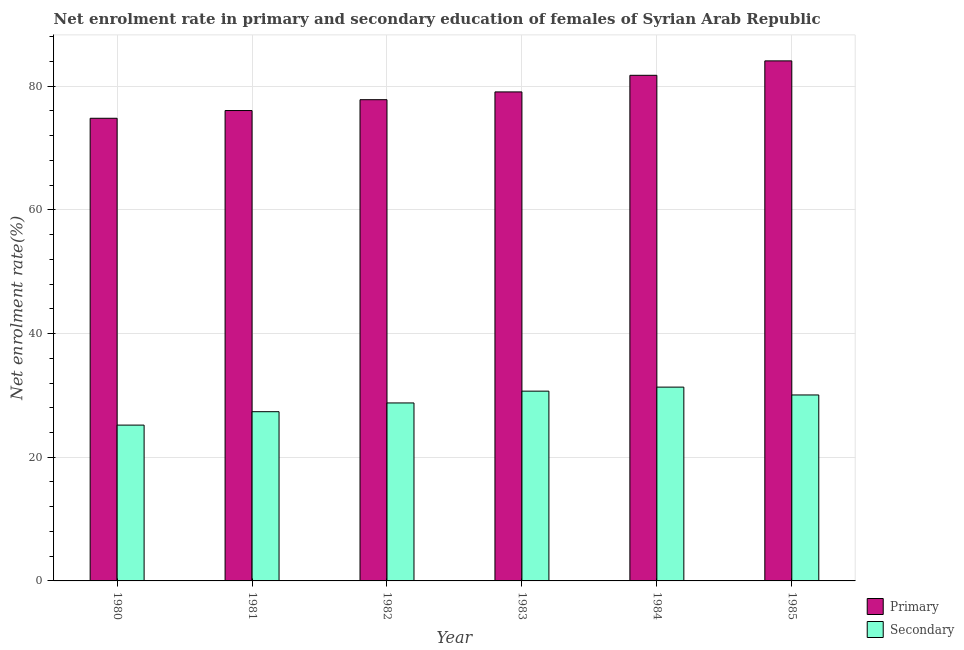How many different coloured bars are there?
Offer a very short reply. 2. How many groups of bars are there?
Provide a short and direct response. 6. Are the number of bars on each tick of the X-axis equal?
Provide a succinct answer. Yes. How many bars are there on the 6th tick from the left?
Provide a short and direct response. 2. What is the enrollment rate in primary education in 1984?
Provide a short and direct response. 81.76. Across all years, what is the maximum enrollment rate in primary education?
Keep it short and to the point. 84.09. Across all years, what is the minimum enrollment rate in secondary education?
Give a very brief answer. 25.2. What is the total enrollment rate in primary education in the graph?
Give a very brief answer. 473.62. What is the difference between the enrollment rate in primary education in 1981 and that in 1982?
Offer a very short reply. -1.75. What is the difference between the enrollment rate in primary education in 1982 and the enrollment rate in secondary education in 1983?
Give a very brief answer. -1.26. What is the average enrollment rate in secondary education per year?
Your answer should be compact. 28.91. In how many years, is the enrollment rate in primary education greater than 12 %?
Provide a succinct answer. 6. What is the ratio of the enrollment rate in secondary education in 1982 to that in 1983?
Keep it short and to the point. 0.94. Is the enrollment rate in secondary education in 1981 less than that in 1983?
Offer a terse response. Yes. What is the difference between the highest and the second highest enrollment rate in secondary education?
Make the answer very short. 0.65. What is the difference between the highest and the lowest enrollment rate in primary education?
Keep it short and to the point. 9.28. In how many years, is the enrollment rate in primary education greater than the average enrollment rate in primary education taken over all years?
Offer a very short reply. 3. What does the 1st bar from the left in 1980 represents?
Provide a succinct answer. Primary. What does the 2nd bar from the right in 1984 represents?
Ensure brevity in your answer.  Primary. How many bars are there?
Offer a terse response. 12. Are all the bars in the graph horizontal?
Your answer should be compact. No. Are the values on the major ticks of Y-axis written in scientific E-notation?
Your response must be concise. No. Where does the legend appear in the graph?
Your answer should be very brief. Bottom right. How are the legend labels stacked?
Your answer should be very brief. Vertical. What is the title of the graph?
Your response must be concise. Net enrolment rate in primary and secondary education of females of Syrian Arab Republic. What is the label or title of the X-axis?
Give a very brief answer. Year. What is the label or title of the Y-axis?
Offer a very short reply. Net enrolment rate(%). What is the Net enrolment rate(%) of Primary in 1980?
Ensure brevity in your answer.  74.81. What is the Net enrolment rate(%) in Secondary in 1980?
Offer a terse response. 25.2. What is the Net enrolment rate(%) in Primary in 1981?
Provide a succinct answer. 76.06. What is the Net enrolment rate(%) of Secondary in 1981?
Offer a very short reply. 27.37. What is the Net enrolment rate(%) in Primary in 1982?
Ensure brevity in your answer.  77.82. What is the Net enrolment rate(%) in Secondary in 1982?
Ensure brevity in your answer.  28.78. What is the Net enrolment rate(%) of Primary in 1983?
Your answer should be very brief. 79.07. What is the Net enrolment rate(%) of Secondary in 1983?
Make the answer very short. 30.69. What is the Net enrolment rate(%) of Primary in 1984?
Keep it short and to the point. 81.76. What is the Net enrolment rate(%) in Secondary in 1984?
Your response must be concise. 31.34. What is the Net enrolment rate(%) in Primary in 1985?
Your response must be concise. 84.09. What is the Net enrolment rate(%) in Secondary in 1985?
Offer a very short reply. 30.07. Across all years, what is the maximum Net enrolment rate(%) in Primary?
Provide a succinct answer. 84.09. Across all years, what is the maximum Net enrolment rate(%) in Secondary?
Offer a very short reply. 31.34. Across all years, what is the minimum Net enrolment rate(%) of Primary?
Keep it short and to the point. 74.81. Across all years, what is the minimum Net enrolment rate(%) in Secondary?
Your answer should be compact. 25.2. What is the total Net enrolment rate(%) in Primary in the graph?
Your response must be concise. 473.62. What is the total Net enrolment rate(%) in Secondary in the graph?
Give a very brief answer. 173.44. What is the difference between the Net enrolment rate(%) of Primary in 1980 and that in 1981?
Provide a succinct answer. -1.25. What is the difference between the Net enrolment rate(%) of Secondary in 1980 and that in 1981?
Give a very brief answer. -2.17. What is the difference between the Net enrolment rate(%) in Primary in 1980 and that in 1982?
Your response must be concise. -3. What is the difference between the Net enrolment rate(%) of Secondary in 1980 and that in 1982?
Make the answer very short. -3.58. What is the difference between the Net enrolment rate(%) of Primary in 1980 and that in 1983?
Your answer should be compact. -4.26. What is the difference between the Net enrolment rate(%) of Secondary in 1980 and that in 1983?
Ensure brevity in your answer.  -5.49. What is the difference between the Net enrolment rate(%) in Primary in 1980 and that in 1984?
Your response must be concise. -6.95. What is the difference between the Net enrolment rate(%) of Secondary in 1980 and that in 1984?
Your answer should be compact. -6.14. What is the difference between the Net enrolment rate(%) in Primary in 1980 and that in 1985?
Your answer should be compact. -9.28. What is the difference between the Net enrolment rate(%) of Secondary in 1980 and that in 1985?
Make the answer very short. -4.87. What is the difference between the Net enrolment rate(%) in Primary in 1981 and that in 1982?
Keep it short and to the point. -1.75. What is the difference between the Net enrolment rate(%) of Secondary in 1981 and that in 1982?
Give a very brief answer. -1.41. What is the difference between the Net enrolment rate(%) in Primary in 1981 and that in 1983?
Offer a terse response. -3.01. What is the difference between the Net enrolment rate(%) of Secondary in 1981 and that in 1983?
Your answer should be compact. -3.32. What is the difference between the Net enrolment rate(%) in Primary in 1981 and that in 1984?
Keep it short and to the point. -5.7. What is the difference between the Net enrolment rate(%) in Secondary in 1981 and that in 1984?
Your answer should be very brief. -3.97. What is the difference between the Net enrolment rate(%) in Primary in 1981 and that in 1985?
Offer a terse response. -8.03. What is the difference between the Net enrolment rate(%) in Secondary in 1981 and that in 1985?
Offer a terse response. -2.71. What is the difference between the Net enrolment rate(%) in Primary in 1982 and that in 1983?
Offer a terse response. -1.26. What is the difference between the Net enrolment rate(%) in Secondary in 1982 and that in 1983?
Your answer should be compact. -1.91. What is the difference between the Net enrolment rate(%) in Primary in 1982 and that in 1984?
Offer a very short reply. -3.94. What is the difference between the Net enrolment rate(%) of Secondary in 1982 and that in 1984?
Your answer should be very brief. -2.56. What is the difference between the Net enrolment rate(%) of Primary in 1982 and that in 1985?
Provide a short and direct response. -6.28. What is the difference between the Net enrolment rate(%) of Secondary in 1982 and that in 1985?
Provide a short and direct response. -1.29. What is the difference between the Net enrolment rate(%) in Primary in 1983 and that in 1984?
Keep it short and to the point. -2.69. What is the difference between the Net enrolment rate(%) in Secondary in 1983 and that in 1984?
Give a very brief answer. -0.65. What is the difference between the Net enrolment rate(%) of Primary in 1983 and that in 1985?
Ensure brevity in your answer.  -5.02. What is the difference between the Net enrolment rate(%) in Secondary in 1983 and that in 1985?
Provide a succinct answer. 0.62. What is the difference between the Net enrolment rate(%) in Primary in 1984 and that in 1985?
Provide a succinct answer. -2.33. What is the difference between the Net enrolment rate(%) of Secondary in 1984 and that in 1985?
Ensure brevity in your answer.  1.27. What is the difference between the Net enrolment rate(%) of Primary in 1980 and the Net enrolment rate(%) of Secondary in 1981?
Offer a very short reply. 47.45. What is the difference between the Net enrolment rate(%) in Primary in 1980 and the Net enrolment rate(%) in Secondary in 1982?
Give a very brief answer. 46.03. What is the difference between the Net enrolment rate(%) of Primary in 1980 and the Net enrolment rate(%) of Secondary in 1983?
Your answer should be very brief. 44.12. What is the difference between the Net enrolment rate(%) in Primary in 1980 and the Net enrolment rate(%) in Secondary in 1984?
Ensure brevity in your answer.  43.47. What is the difference between the Net enrolment rate(%) of Primary in 1980 and the Net enrolment rate(%) of Secondary in 1985?
Provide a short and direct response. 44.74. What is the difference between the Net enrolment rate(%) in Primary in 1981 and the Net enrolment rate(%) in Secondary in 1982?
Make the answer very short. 47.28. What is the difference between the Net enrolment rate(%) in Primary in 1981 and the Net enrolment rate(%) in Secondary in 1983?
Keep it short and to the point. 45.37. What is the difference between the Net enrolment rate(%) of Primary in 1981 and the Net enrolment rate(%) of Secondary in 1984?
Make the answer very short. 44.72. What is the difference between the Net enrolment rate(%) in Primary in 1981 and the Net enrolment rate(%) in Secondary in 1985?
Offer a very short reply. 45.99. What is the difference between the Net enrolment rate(%) in Primary in 1982 and the Net enrolment rate(%) in Secondary in 1983?
Ensure brevity in your answer.  47.13. What is the difference between the Net enrolment rate(%) of Primary in 1982 and the Net enrolment rate(%) of Secondary in 1984?
Your response must be concise. 46.48. What is the difference between the Net enrolment rate(%) in Primary in 1982 and the Net enrolment rate(%) in Secondary in 1985?
Offer a very short reply. 47.75. What is the difference between the Net enrolment rate(%) in Primary in 1983 and the Net enrolment rate(%) in Secondary in 1984?
Offer a very short reply. 47.74. What is the difference between the Net enrolment rate(%) in Primary in 1983 and the Net enrolment rate(%) in Secondary in 1985?
Your response must be concise. 49. What is the difference between the Net enrolment rate(%) of Primary in 1984 and the Net enrolment rate(%) of Secondary in 1985?
Your answer should be very brief. 51.69. What is the average Net enrolment rate(%) of Primary per year?
Offer a very short reply. 78.94. What is the average Net enrolment rate(%) in Secondary per year?
Keep it short and to the point. 28.91. In the year 1980, what is the difference between the Net enrolment rate(%) in Primary and Net enrolment rate(%) in Secondary?
Provide a succinct answer. 49.62. In the year 1981, what is the difference between the Net enrolment rate(%) in Primary and Net enrolment rate(%) in Secondary?
Keep it short and to the point. 48.7. In the year 1982, what is the difference between the Net enrolment rate(%) in Primary and Net enrolment rate(%) in Secondary?
Your answer should be compact. 49.04. In the year 1983, what is the difference between the Net enrolment rate(%) of Primary and Net enrolment rate(%) of Secondary?
Ensure brevity in your answer.  48.39. In the year 1984, what is the difference between the Net enrolment rate(%) of Primary and Net enrolment rate(%) of Secondary?
Your response must be concise. 50.42. In the year 1985, what is the difference between the Net enrolment rate(%) in Primary and Net enrolment rate(%) in Secondary?
Provide a short and direct response. 54.02. What is the ratio of the Net enrolment rate(%) of Primary in 1980 to that in 1981?
Offer a terse response. 0.98. What is the ratio of the Net enrolment rate(%) in Secondary in 1980 to that in 1981?
Provide a short and direct response. 0.92. What is the ratio of the Net enrolment rate(%) of Primary in 1980 to that in 1982?
Your answer should be compact. 0.96. What is the ratio of the Net enrolment rate(%) of Secondary in 1980 to that in 1982?
Offer a very short reply. 0.88. What is the ratio of the Net enrolment rate(%) of Primary in 1980 to that in 1983?
Provide a short and direct response. 0.95. What is the ratio of the Net enrolment rate(%) in Secondary in 1980 to that in 1983?
Ensure brevity in your answer.  0.82. What is the ratio of the Net enrolment rate(%) in Primary in 1980 to that in 1984?
Your answer should be very brief. 0.92. What is the ratio of the Net enrolment rate(%) of Secondary in 1980 to that in 1984?
Offer a very short reply. 0.8. What is the ratio of the Net enrolment rate(%) in Primary in 1980 to that in 1985?
Ensure brevity in your answer.  0.89. What is the ratio of the Net enrolment rate(%) in Secondary in 1980 to that in 1985?
Your response must be concise. 0.84. What is the ratio of the Net enrolment rate(%) of Primary in 1981 to that in 1982?
Offer a terse response. 0.98. What is the ratio of the Net enrolment rate(%) of Secondary in 1981 to that in 1982?
Provide a succinct answer. 0.95. What is the ratio of the Net enrolment rate(%) of Primary in 1981 to that in 1983?
Give a very brief answer. 0.96. What is the ratio of the Net enrolment rate(%) of Secondary in 1981 to that in 1983?
Give a very brief answer. 0.89. What is the ratio of the Net enrolment rate(%) in Primary in 1981 to that in 1984?
Provide a short and direct response. 0.93. What is the ratio of the Net enrolment rate(%) of Secondary in 1981 to that in 1984?
Keep it short and to the point. 0.87. What is the ratio of the Net enrolment rate(%) of Primary in 1981 to that in 1985?
Your answer should be compact. 0.9. What is the ratio of the Net enrolment rate(%) in Secondary in 1981 to that in 1985?
Provide a succinct answer. 0.91. What is the ratio of the Net enrolment rate(%) of Primary in 1982 to that in 1983?
Offer a terse response. 0.98. What is the ratio of the Net enrolment rate(%) in Secondary in 1982 to that in 1983?
Your response must be concise. 0.94. What is the ratio of the Net enrolment rate(%) in Primary in 1982 to that in 1984?
Give a very brief answer. 0.95. What is the ratio of the Net enrolment rate(%) of Secondary in 1982 to that in 1984?
Your answer should be compact. 0.92. What is the ratio of the Net enrolment rate(%) in Primary in 1982 to that in 1985?
Offer a terse response. 0.93. What is the ratio of the Net enrolment rate(%) in Secondary in 1982 to that in 1985?
Ensure brevity in your answer.  0.96. What is the ratio of the Net enrolment rate(%) in Primary in 1983 to that in 1984?
Your response must be concise. 0.97. What is the ratio of the Net enrolment rate(%) of Secondary in 1983 to that in 1984?
Your answer should be very brief. 0.98. What is the ratio of the Net enrolment rate(%) in Primary in 1983 to that in 1985?
Provide a succinct answer. 0.94. What is the ratio of the Net enrolment rate(%) of Secondary in 1983 to that in 1985?
Your answer should be compact. 1.02. What is the ratio of the Net enrolment rate(%) of Primary in 1984 to that in 1985?
Your answer should be very brief. 0.97. What is the ratio of the Net enrolment rate(%) in Secondary in 1984 to that in 1985?
Your answer should be very brief. 1.04. What is the difference between the highest and the second highest Net enrolment rate(%) in Primary?
Offer a terse response. 2.33. What is the difference between the highest and the second highest Net enrolment rate(%) in Secondary?
Ensure brevity in your answer.  0.65. What is the difference between the highest and the lowest Net enrolment rate(%) of Primary?
Make the answer very short. 9.28. What is the difference between the highest and the lowest Net enrolment rate(%) in Secondary?
Offer a terse response. 6.14. 